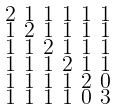<formula> <loc_0><loc_0><loc_500><loc_500>\begin{smallmatrix} 2 & 1 & 1 & 1 & 1 & 1 \\ 1 & 2 & 1 & 1 & 1 & 1 \\ 1 & 1 & 2 & 1 & 1 & 1 \\ 1 & 1 & 1 & 2 & 1 & 1 \\ 1 & 1 & 1 & 1 & 2 & 0 \\ 1 & 1 & 1 & 1 & 0 & 3 \end{smallmatrix}</formula> 